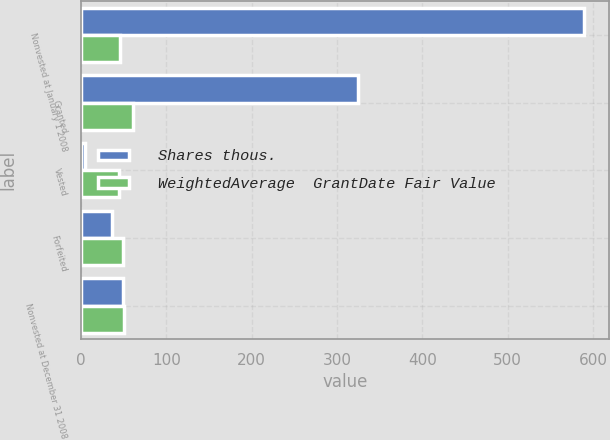<chart> <loc_0><loc_0><loc_500><loc_500><stacked_bar_chart><ecel><fcel>Nonvested at January 1 2008<fcel>Granted<fcel>Vested<fcel>Forfeited<fcel>Nonvested at December 31 2008<nl><fcel>Shares thous.<fcel>589<fcel>325<fcel>5<fcel>36<fcel>49.13<nl><fcel>WeightedAverage  GrantDate Fair Value<fcel>45.27<fcel>60.25<fcel>43.91<fcel>49.13<fcel>50.7<nl></chart> 